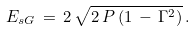Convert formula to latex. <formula><loc_0><loc_0><loc_500><loc_500>E _ { s G } \, = \, 2 \, \sqrt { 2 \, P \, ( 1 \, - \, \Gamma ^ { 2 } ) } \, .</formula> 